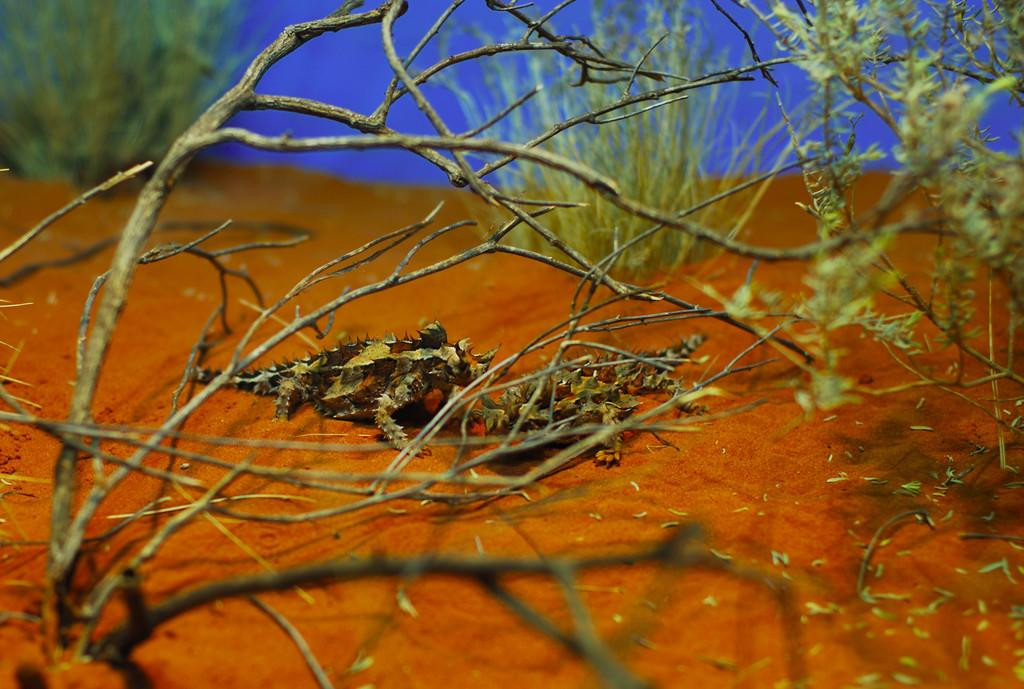What type of animals are on the ground in the image? There are reptiles on the ground in the image. What other living organisms can be seen in the image? There are plants in the image. Can you describe a specific feature of the natural environment in the image? There is a tree in the image. What type of representative is present in the image? There is no representative present in the image; it features reptiles, plants, and a tree. Can you tell me what note is being played in the image? There is no note being played in the image, as it does not depict any musical instruments or sounds. 